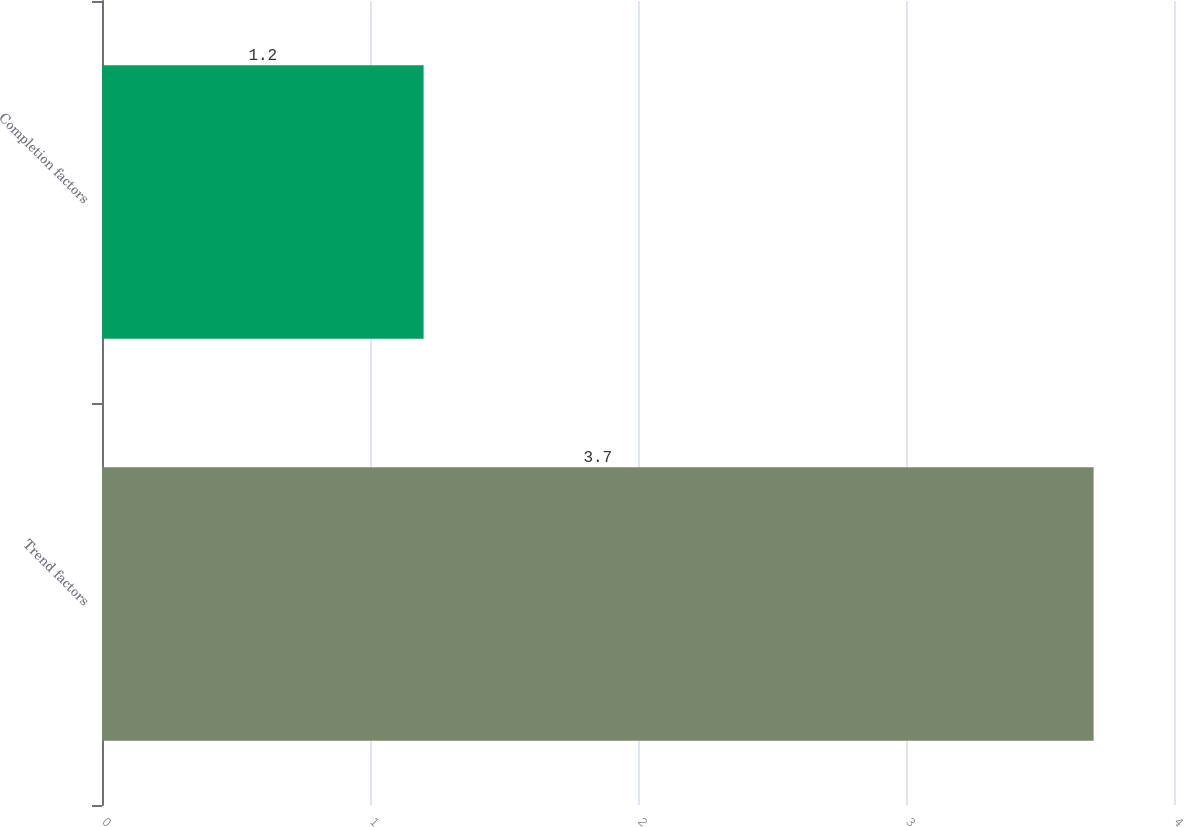Convert chart. <chart><loc_0><loc_0><loc_500><loc_500><bar_chart><fcel>Trend factors<fcel>Completion factors<nl><fcel>3.7<fcel>1.2<nl></chart> 